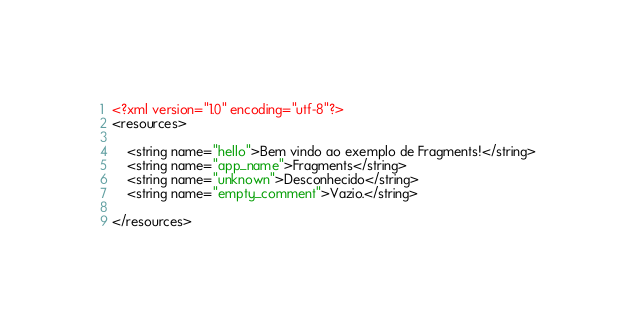Convert code to text. <code><loc_0><loc_0><loc_500><loc_500><_XML_><?xml version="1.0" encoding="utf-8"?>
<resources>

    <string name="hello">Bem vindo ao exemplo de Fragments!</string>
    <string name="app_name">Fragments</string>
    <string name="unknown">Desconhecido</string>
    <string name="empty_comment">Vazio.</string>
    
</resources></code> 